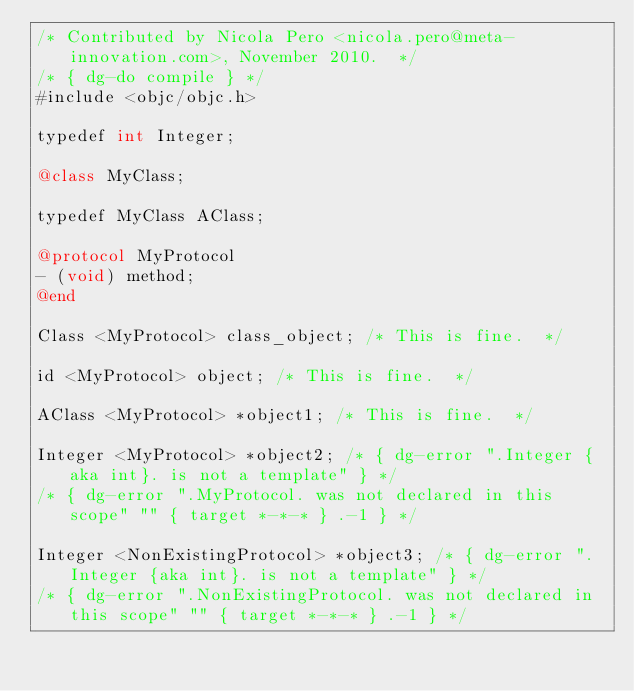Convert code to text. <code><loc_0><loc_0><loc_500><loc_500><_ObjectiveC_>/* Contributed by Nicola Pero <nicola.pero@meta-innovation.com>, November 2010.  */
/* { dg-do compile } */
#include <objc/objc.h>

typedef int Integer;

@class MyClass;

typedef MyClass AClass;

@protocol MyProtocol
- (void) method;
@end

Class <MyProtocol> class_object; /* This is fine.  */

id <MyProtocol> object; /* This is fine.  */

AClass <MyProtocol> *object1; /* This is fine.  */

Integer <MyProtocol> *object2; /* { dg-error ".Integer {aka int}. is not a template" } */
/* { dg-error ".MyProtocol. was not declared in this scope" "" { target *-*-* } .-1 } */

Integer <NonExistingProtocol> *object3; /* { dg-error ".Integer {aka int}. is not a template" } */
/* { dg-error ".NonExistingProtocol. was not declared in this scope" "" { target *-*-* } .-1 } */
</code> 